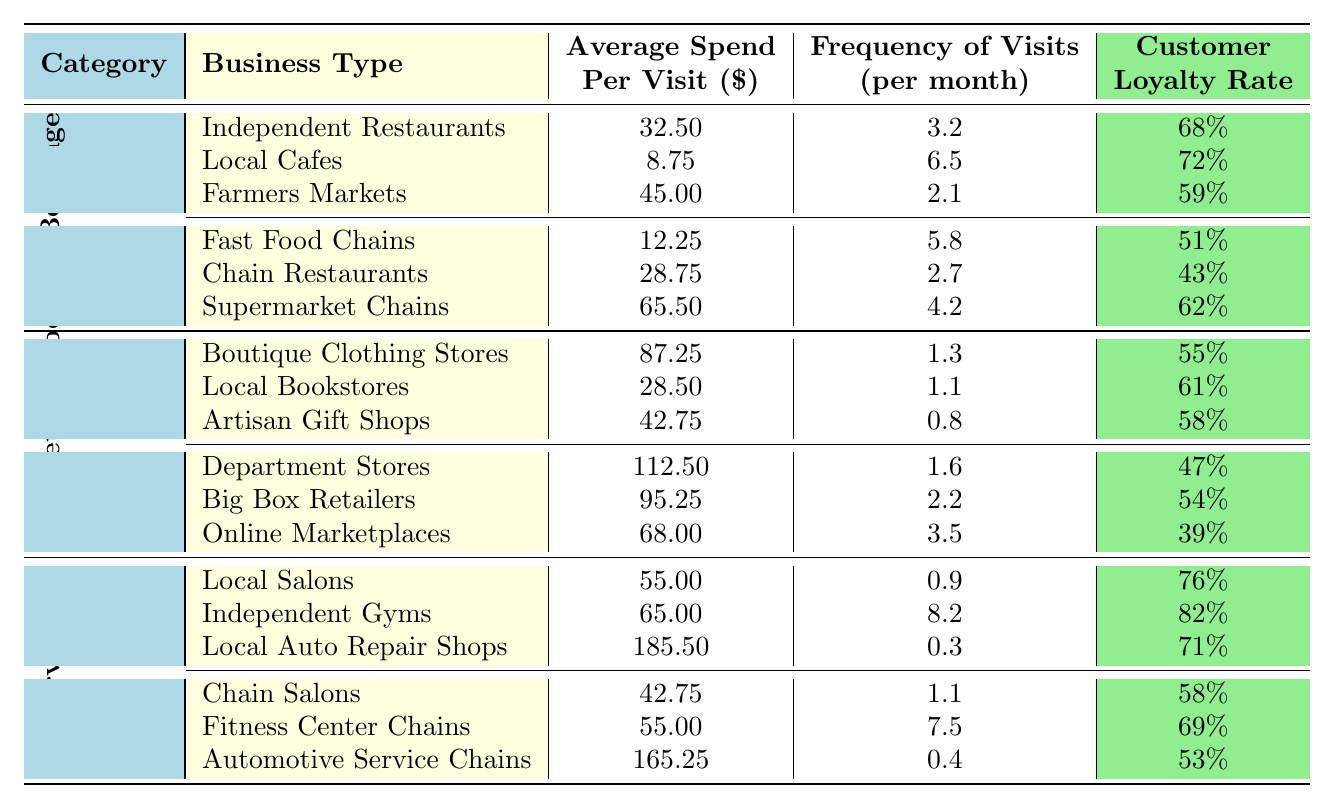What is the average spend per visit at Independent Restaurants? The average spend per visit for Independent Restaurants is provided directly in the table under the Food and Beverage section. It is listed as $32.50.
Answer: $32.50 Which local business type has the highest frequency of visits per month? To answer this, we compare the frequency of visits for all local business types listed in the table. Local Cafes have the highest frequency at 6.5 visits per month.
Answer: Local Cafes How many customers visit Farmers Markets on average each month? The table shows that the frequency of visits for Farmers Markets is 2.1 times per month.
Answer: 2.1 Is the customer loyalty rate higher for Local Cafes compared to Fast Food Chains? The customer loyalty rate for Local Cafes is 72%, while for Fast Food Chains it is 51%. Since 72% is higher than 51%, the statement is true.
Answer: Yes What is the total average spend per visit for all local businesses in the Food and Beverage category? We sum the average spend per visit for all 3 local business types: 32.50 (Independent Restaurants) + 8.75 (Local Cafes) + 45.00 (Farmers Markets) = 86.25, so the total is $86.25.
Answer: $86.25 What is the difference in average spend per visit between the highest and lowest local business types in Retail? The highest is Boutique Clothing Stores at $87.25 and the lowest is Artisan Gift Shops at $42.75. The difference is $87.25 - $42.75 = $44.50.
Answer: $44.50 Which type of chain business has the lowest customer loyalty rate? We compare the customer loyalty rates for all chain businesses listed. Online Marketplaces has the lowest loyalty rate at 39%.
Answer: Online Marketplaces What is the average frequency of visits for Independent Gyms and Fitness Center Chains combined? We first note the frequency of visits: Independent Gyms is 8.2 and Fitness Center Chains is 7.5. So, the average combined is (8.2 + 7.5) / 2 = 7.85.
Answer: 7.85 Does the average spend per visit in Department Stores exceed the average spend per visit in Local Bookstores? The average spend for Department Stores is $112.50 and for Local Bookstores it is $28.50. Since $112.50 exceeds $28.50, the statement is true.
Answer: Yes What is the average customer loyalty rate for all local businesses in the Services category? The rates for Local Salons, Independent Gyms, and Local Auto Repair Shops are 76%, 82%, and 71%. The average is (76 + 82 + 71) / 3 = 76.33%.
Answer: 76.33% 